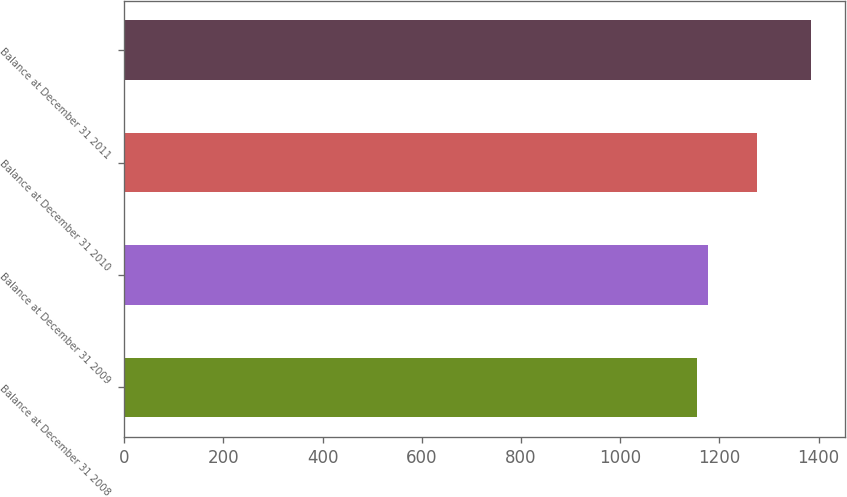<chart> <loc_0><loc_0><loc_500><loc_500><bar_chart><fcel>Balance at December 31 2008<fcel>Balance at December 31 2009<fcel>Balance at December 31 2010<fcel>Balance at December 31 2011<nl><fcel>1155<fcel>1177.9<fcel>1275<fcel>1384<nl></chart> 